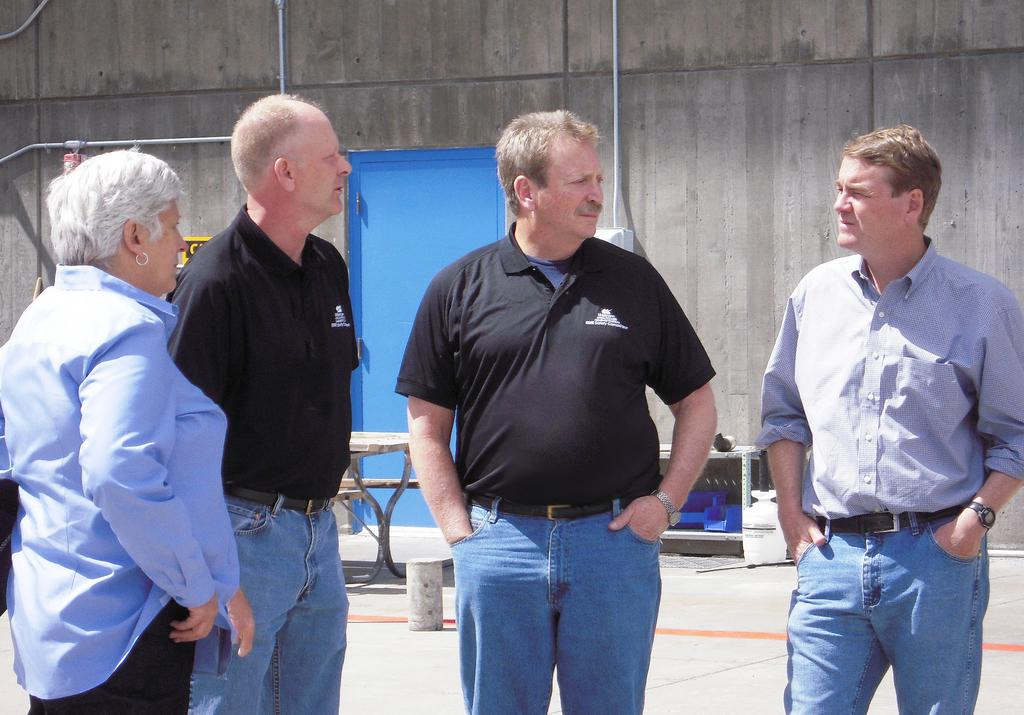What is happening among the people in the image? There are four people standing and talking to each other. What can be seen in the background of the image? A: There is a blue colored door and a table in the background. What is the setting of the scene? The scene appears to be in front of a building wall. What type of smell can be detected coming from the brick in the image? There is no brick present in the image, so it is not possible to determine any smell associated with it. 